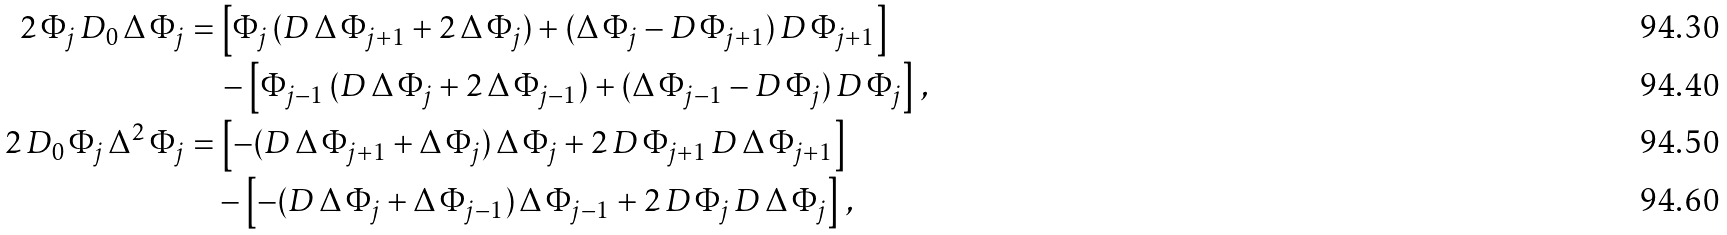Convert formula to latex. <formula><loc_0><loc_0><loc_500><loc_500>2 \, \Phi _ { j } \, D _ { 0 } \, \Delta \, \Phi _ { j } = & \, \left [ \Phi _ { j } \, ( D \, \Delta \, \Phi _ { j + 1 } + 2 \, \Delta \, \Phi _ { j } ) + ( \Delta \, \Phi _ { j } - D \, \Phi _ { j + 1 } ) \, D \, \Phi _ { j + 1 } \right ] \\ & \, - \left [ \Phi _ { j - 1 } \, ( D \, \Delta \, \Phi _ { j } + 2 \, \Delta \, \Phi _ { j - 1 } ) + ( \Delta \, \Phi _ { j - 1 } - D \, \Phi _ { j } ) \, D \, \Phi _ { j } \right ] \, , \\ 2 \, D _ { 0 } \, \Phi _ { j } \, \Delta ^ { 2 } \, \Phi _ { j } = & \, \left [ - ( D \, \Delta \, \Phi _ { j + 1 } + \Delta \, \Phi _ { j } ) \, \Delta \, \Phi _ { j } + 2 \, D \, \Phi _ { j + 1 } \, D \, \Delta \, \Phi _ { j + 1 } \right ] \\ & - \left [ - ( D \, \Delta \, \Phi _ { j } + \Delta \, \Phi _ { j - 1 } ) \, \Delta \, \Phi _ { j - 1 } + 2 \, D \, \Phi _ { j } \, D \, \Delta \, \Phi _ { j } \right ] \, ,</formula> 